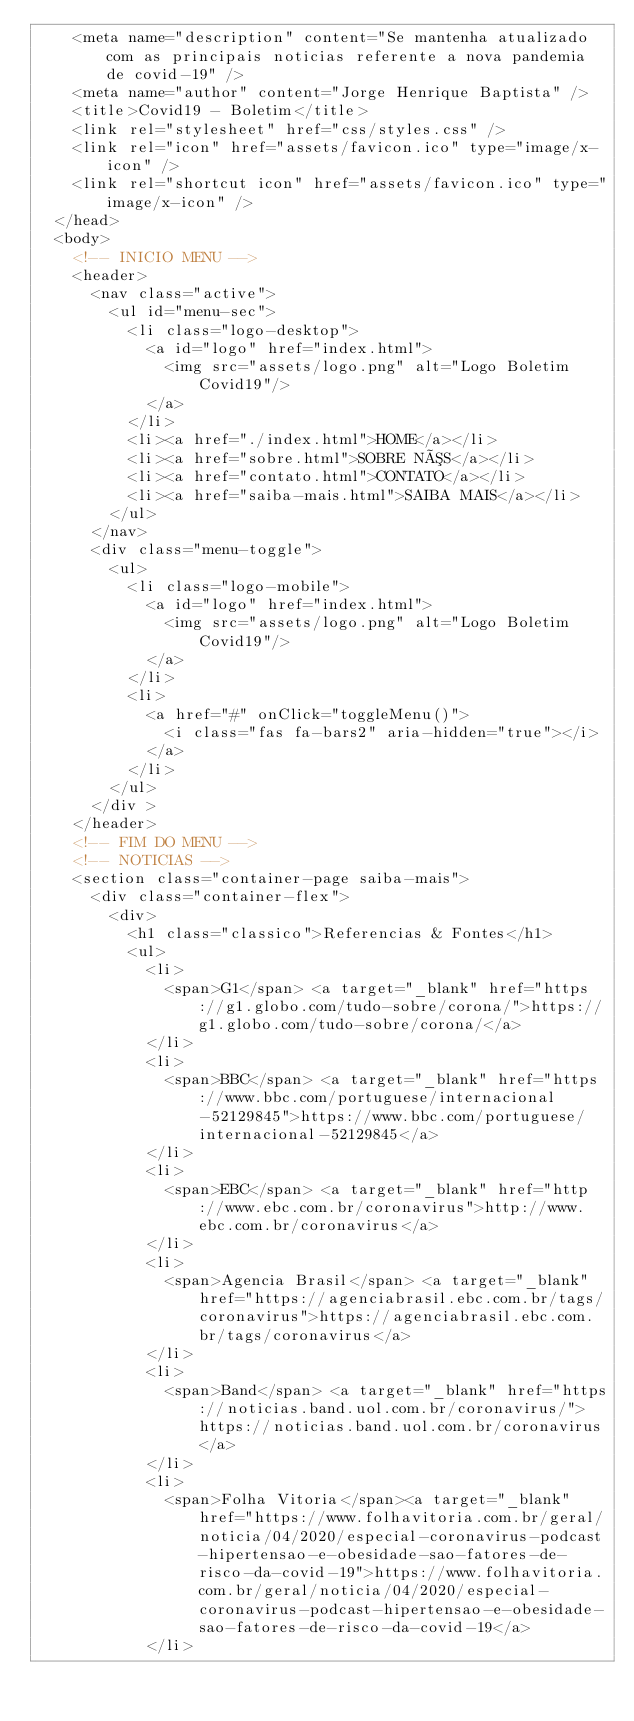<code> <loc_0><loc_0><loc_500><loc_500><_HTML_>    <meta name="description" content="Se mantenha atualizado com as principais noticias referente a nova pandemia de covid-19" />
    <meta name="author" content="Jorge Henrique Baptista" />
    <title>Covid19 - Boletim</title>
    <link rel="stylesheet" href="css/styles.css" />
    <link rel="icon" href="assets/favicon.ico" type="image/x-icon" />
    <link rel="shortcut icon" href="assets/favicon.ico" type="image/x-icon" />
  </head>
  <body>
    <!-- INICIO MENU -->
    <header>
      <nav class="active">
        <ul id="menu-sec">
          <li class="logo-desktop">
            <a id="logo" href="index.html">
              <img src="assets/logo.png" alt="Logo Boletim Covid19"/>
            </a>
          </li>
          <li><a href="./index.html">HOME</a></li>
          <li><a href="sobre.html">SOBRE NÓS</a></li>
          <li><a href="contato.html">CONTATO</a></li>
          <li><a href="saiba-mais.html">SAIBA MAIS</a></li>
        </ul>
      </nav>
      <div class="menu-toggle">
        <ul>
          <li class="logo-mobile">
            <a id="logo" href="index.html">
              <img src="assets/logo.png" alt="Logo Boletim Covid19"/>
            </a>
          </li>
          <li>
            <a href="#" onClick="toggleMenu()">
              <i class="fas fa-bars2" aria-hidden="true"></i>
            </a>
          </li>
        </ul>
      </div >
    </header>
    <!-- FIM DO MENU -->
    <!-- NOTICIAS -->
    <section class="container-page saiba-mais">
      <div class="container-flex">
        <div>
          <h1 class="classico">Referencias & Fontes</h1>
          <ul>
            <li>
              <span>G1</span> <a target="_blank" href="https://g1.globo.com/tudo-sobre/corona/">https://g1.globo.com/tudo-sobre/corona/</a>
            </li>
            <li>
              <span>BBC</span> <a target="_blank" href="https://www.bbc.com/portuguese/internacional-52129845">https://www.bbc.com/portuguese/internacional-52129845</a>
            </li>
            <li>
              <span>EBC</span> <a target="_blank" href="http://www.ebc.com.br/coronavirus">http://www.ebc.com.br/coronavirus</a>
            </li>
            <li>
              <span>Agencia Brasil</span> <a target="_blank" href="https://agenciabrasil.ebc.com.br/tags/coronavirus">https://agenciabrasil.ebc.com.br/tags/coronavirus</a>
            </li>
            <li>
              <span>Band</span> <a target="_blank" href="https://noticias.band.uol.com.br/coronavirus/"> https://noticias.band.uol.com.br/coronavirus</a>
            </li>
            <li>
              <span>Folha Vitoria</span><a target="_blank" href="https://www.folhavitoria.com.br/geral/noticia/04/2020/especial-coronavirus-podcast-hipertensao-e-obesidade-sao-fatores-de-risco-da-covid-19">https://www.folhavitoria.com.br/geral/noticia/04/2020/especial-coronavirus-podcast-hipertensao-e-obesidade-sao-fatores-de-risco-da-covid-19</a>
            </li></code> 